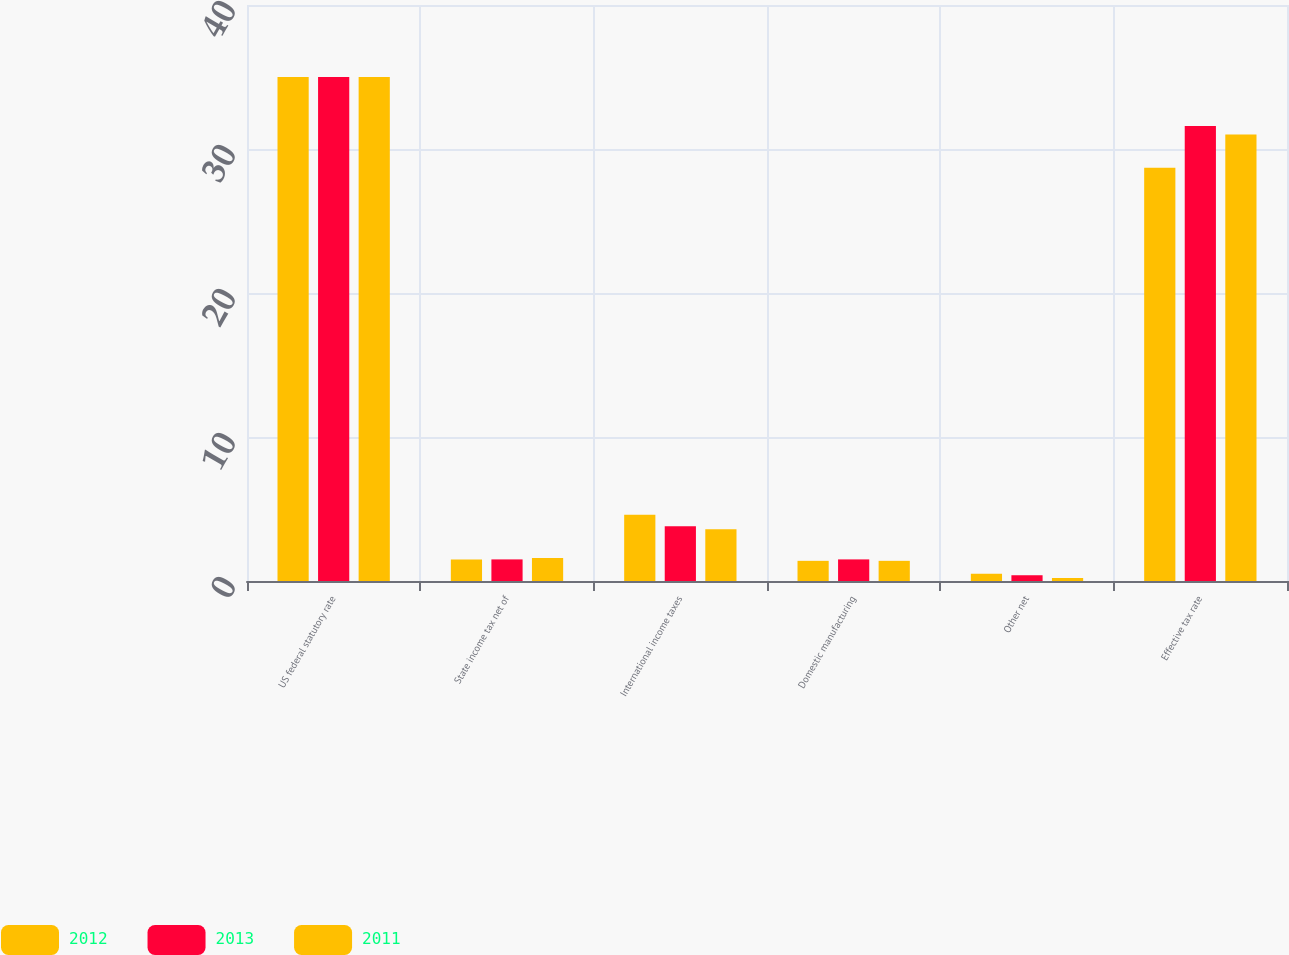<chart> <loc_0><loc_0><loc_500><loc_500><stacked_bar_chart><ecel><fcel>US federal statutory rate<fcel>State income tax net of<fcel>International income taxes<fcel>Domestic manufacturing<fcel>Other net<fcel>Effective tax rate<nl><fcel>2012<fcel>35<fcel>1.5<fcel>4.6<fcel>1.4<fcel>0.5<fcel>28.7<nl><fcel>2013<fcel>35<fcel>1.5<fcel>3.8<fcel>1.5<fcel>0.4<fcel>31.6<nl><fcel>2011<fcel>35<fcel>1.6<fcel>3.6<fcel>1.4<fcel>0.2<fcel>31<nl></chart> 